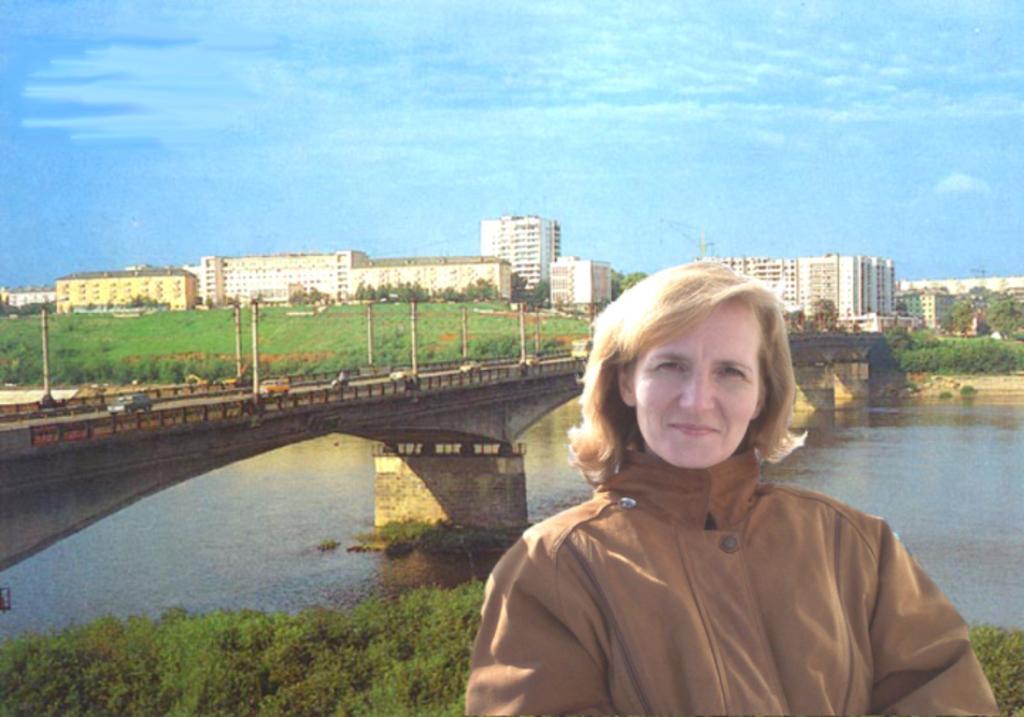Describe this image in one or two sentences. In this picture there is a woman who is wearing brown jacket. Behind her I can see the water and bridge. On the bridge I can see the cars, bus and other vehicles. Beside that I can see the street lights, poles and fencing. In the background I can see the buildings, trees, plants and other objects. At the top I can see the sky and clouds. 